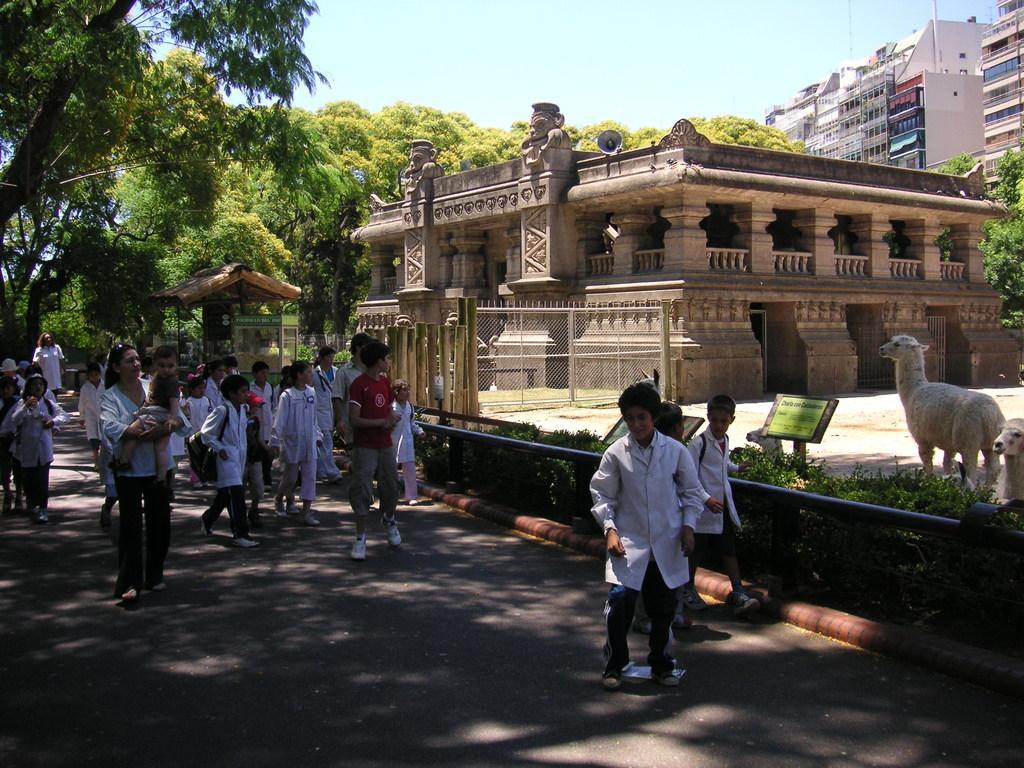Describe this image in one or two sentences. In this image I can see group of people some are standing and some are walking, they are wearing white color dress. Background I can see building in cream color, trees in green color, sky in white and blue color. 